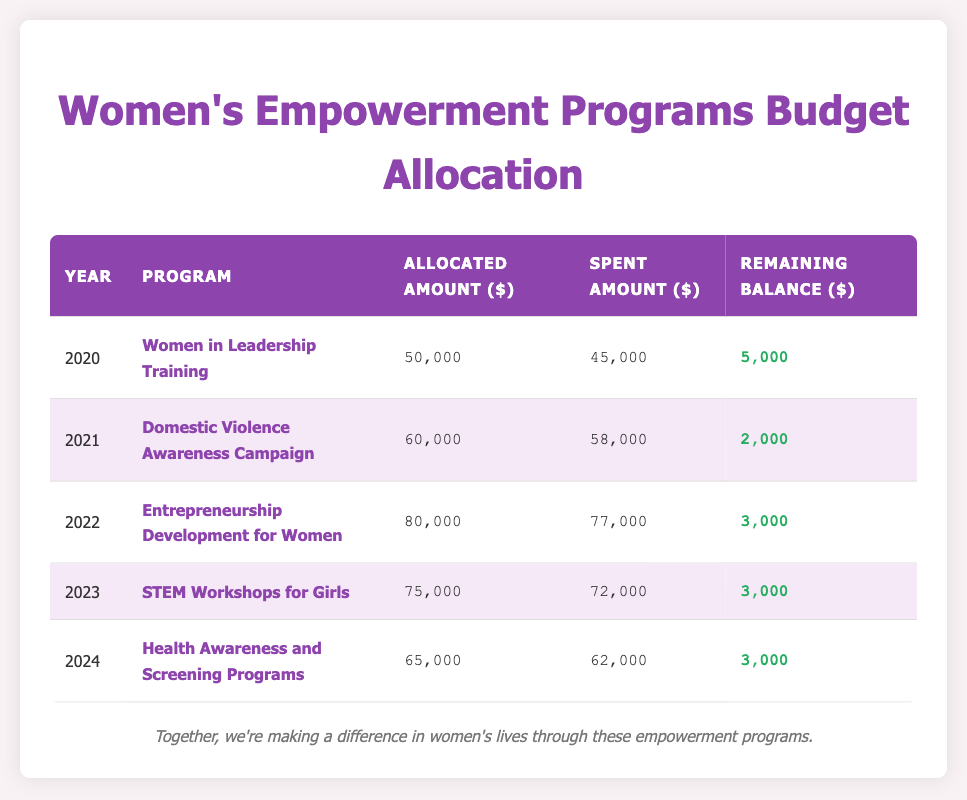What was the allocated amount for the Domestic Violence Awareness Campaign in 2021? The table indicates that the allocated amount for the Domestic Violence Awareness Campaign in 2021 is listed directly under "Allocated Amount ($)" for that year and program, which is 60,000.
Answer: 60,000 What is the remaining balance for the Women in Leadership Training program? The remaining balance for the Women in Leadership Training program can be found in the table under the "Remaining Balance ($)" column for the year 2020, which shows 5,000.
Answer: 5,000 What was the total allocated amount for all programs from 2020 to 2024? To find the total allocated amount, sum the allocated amounts for each year: 50,000 + 60,000 + 80,000 + 75,000 + 65,000 = 330,000.
Answer: 330,000 Was the spent amount for the Entrepreneurship Development for Women program higher than the allocated amount? Checking the table for the year 2022, the spent amount is 77,000 while the allocated amount is 80,000. Since 77,000 is less than 80,000, the statement is false.
Answer: No How much money is remaining in total across all programs as of 2024? To find the total remaining balance, add up the remaining balances from each program: 5,000 (2020) + 2,000 (2021) + 3,000 (2022) + 3,000 (2023) + 3,000 (2024) = 16,000.
Answer: 16,000 Which program had the highest allocated amount and what was that amount? By examining the table, the program with the highest allocated amount is the Entrepreneurship Development for Women in 2022, with an amount of 80,000.
Answer: 80,000 What percentage of the allocated budget was spent in 2023 on the STEM Workshops for Girls? To calculate the percentage spent, use the formula: (spent amount / allocated amount) * 100 = (72,000 / 75,000) * 100 = 96%.
Answer: 96% Is it true that the allocated amount for Health Awareness and Screening Programs is lower than that of the Women in Leadership Training? Comparing the allocated amounts, the Health Awareness and Screening Programs in 2024 have an amount of 65,000, while the Women in Leadership Training in 2020 is 50,000; since 65,000 is greater than 50,000, the statement is false.
Answer: No 